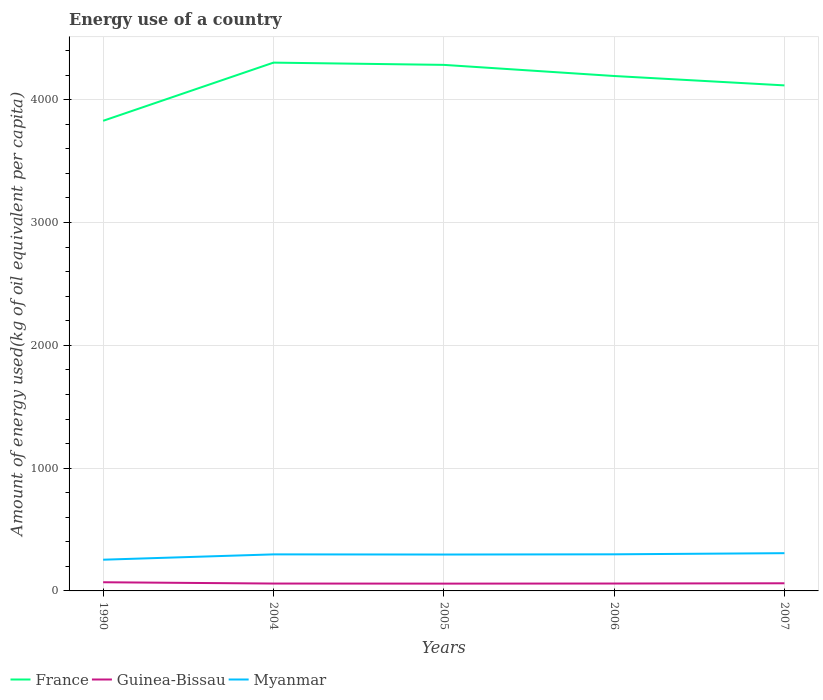How many different coloured lines are there?
Offer a terse response. 3. Does the line corresponding to France intersect with the line corresponding to Guinea-Bissau?
Provide a succinct answer. No. Across all years, what is the maximum amount of energy used in in Guinea-Bissau?
Give a very brief answer. 59.48. What is the total amount of energy used in in Guinea-Bissau in the graph?
Your response must be concise. -1.98. What is the difference between the highest and the second highest amount of energy used in in Myanmar?
Provide a succinct answer. 53.22. How many lines are there?
Offer a terse response. 3. How many years are there in the graph?
Ensure brevity in your answer.  5. What is the difference between two consecutive major ticks on the Y-axis?
Your response must be concise. 1000. Are the values on the major ticks of Y-axis written in scientific E-notation?
Offer a terse response. No. Does the graph contain grids?
Your answer should be very brief. Yes. Where does the legend appear in the graph?
Offer a very short reply. Bottom left. What is the title of the graph?
Offer a very short reply. Energy use of a country. What is the label or title of the Y-axis?
Keep it short and to the point. Amount of energy used(kg of oil equivalent per capita). What is the Amount of energy used(kg of oil equivalent per capita) of France in 1990?
Give a very brief answer. 3828.33. What is the Amount of energy used(kg of oil equivalent per capita) of Guinea-Bissau in 1990?
Offer a very short reply. 70.66. What is the Amount of energy used(kg of oil equivalent per capita) of Myanmar in 1990?
Give a very brief answer. 254.23. What is the Amount of energy used(kg of oil equivalent per capita) in France in 2004?
Offer a terse response. 4302.12. What is the Amount of energy used(kg of oil equivalent per capita) in Guinea-Bissau in 2004?
Your answer should be compact. 60.06. What is the Amount of energy used(kg of oil equivalent per capita) in Myanmar in 2004?
Make the answer very short. 297.64. What is the Amount of energy used(kg of oil equivalent per capita) in France in 2005?
Offer a terse response. 4283.8. What is the Amount of energy used(kg of oil equivalent per capita) of Guinea-Bissau in 2005?
Offer a terse response. 59.48. What is the Amount of energy used(kg of oil equivalent per capita) in Myanmar in 2005?
Give a very brief answer. 296.38. What is the Amount of energy used(kg of oil equivalent per capita) in France in 2006?
Give a very brief answer. 4193.22. What is the Amount of energy used(kg of oil equivalent per capita) of Guinea-Bissau in 2006?
Give a very brief answer. 60.22. What is the Amount of energy used(kg of oil equivalent per capita) in Myanmar in 2006?
Your response must be concise. 298.12. What is the Amount of energy used(kg of oil equivalent per capita) in France in 2007?
Make the answer very short. 4116.76. What is the Amount of energy used(kg of oil equivalent per capita) of Guinea-Bissau in 2007?
Provide a short and direct response. 62.2. What is the Amount of energy used(kg of oil equivalent per capita) of Myanmar in 2007?
Keep it short and to the point. 307.44. Across all years, what is the maximum Amount of energy used(kg of oil equivalent per capita) in France?
Provide a short and direct response. 4302.12. Across all years, what is the maximum Amount of energy used(kg of oil equivalent per capita) in Guinea-Bissau?
Your answer should be very brief. 70.66. Across all years, what is the maximum Amount of energy used(kg of oil equivalent per capita) of Myanmar?
Your answer should be very brief. 307.44. Across all years, what is the minimum Amount of energy used(kg of oil equivalent per capita) of France?
Provide a succinct answer. 3828.33. Across all years, what is the minimum Amount of energy used(kg of oil equivalent per capita) of Guinea-Bissau?
Your response must be concise. 59.48. Across all years, what is the minimum Amount of energy used(kg of oil equivalent per capita) in Myanmar?
Ensure brevity in your answer.  254.23. What is the total Amount of energy used(kg of oil equivalent per capita) in France in the graph?
Provide a succinct answer. 2.07e+04. What is the total Amount of energy used(kg of oil equivalent per capita) in Guinea-Bissau in the graph?
Give a very brief answer. 312.62. What is the total Amount of energy used(kg of oil equivalent per capita) of Myanmar in the graph?
Give a very brief answer. 1453.81. What is the difference between the Amount of energy used(kg of oil equivalent per capita) of France in 1990 and that in 2004?
Keep it short and to the point. -473.79. What is the difference between the Amount of energy used(kg of oil equivalent per capita) in Guinea-Bissau in 1990 and that in 2004?
Your answer should be compact. 10.6. What is the difference between the Amount of energy used(kg of oil equivalent per capita) in Myanmar in 1990 and that in 2004?
Provide a short and direct response. -43.42. What is the difference between the Amount of energy used(kg of oil equivalent per capita) in France in 1990 and that in 2005?
Offer a very short reply. -455.48. What is the difference between the Amount of energy used(kg of oil equivalent per capita) in Guinea-Bissau in 1990 and that in 2005?
Your response must be concise. 11.19. What is the difference between the Amount of energy used(kg of oil equivalent per capita) of Myanmar in 1990 and that in 2005?
Provide a short and direct response. -42.15. What is the difference between the Amount of energy used(kg of oil equivalent per capita) in France in 1990 and that in 2006?
Your answer should be compact. -364.89. What is the difference between the Amount of energy used(kg of oil equivalent per capita) of Guinea-Bissau in 1990 and that in 2006?
Keep it short and to the point. 10.45. What is the difference between the Amount of energy used(kg of oil equivalent per capita) of Myanmar in 1990 and that in 2006?
Keep it short and to the point. -43.89. What is the difference between the Amount of energy used(kg of oil equivalent per capita) of France in 1990 and that in 2007?
Provide a short and direct response. -288.43. What is the difference between the Amount of energy used(kg of oil equivalent per capita) in Guinea-Bissau in 1990 and that in 2007?
Make the answer very short. 8.46. What is the difference between the Amount of energy used(kg of oil equivalent per capita) of Myanmar in 1990 and that in 2007?
Offer a very short reply. -53.22. What is the difference between the Amount of energy used(kg of oil equivalent per capita) in France in 2004 and that in 2005?
Offer a terse response. 18.32. What is the difference between the Amount of energy used(kg of oil equivalent per capita) of Guinea-Bissau in 2004 and that in 2005?
Offer a very short reply. 0.59. What is the difference between the Amount of energy used(kg of oil equivalent per capita) in Myanmar in 2004 and that in 2005?
Give a very brief answer. 1.26. What is the difference between the Amount of energy used(kg of oil equivalent per capita) in France in 2004 and that in 2006?
Provide a short and direct response. 108.9. What is the difference between the Amount of energy used(kg of oil equivalent per capita) of Guinea-Bissau in 2004 and that in 2006?
Provide a short and direct response. -0.15. What is the difference between the Amount of energy used(kg of oil equivalent per capita) in Myanmar in 2004 and that in 2006?
Your response must be concise. -0.47. What is the difference between the Amount of energy used(kg of oil equivalent per capita) of France in 2004 and that in 2007?
Give a very brief answer. 185.36. What is the difference between the Amount of energy used(kg of oil equivalent per capita) of Guinea-Bissau in 2004 and that in 2007?
Make the answer very short. -2.14. What is the difference between the Amount of energy used(kg of oil equivalent per capita) of France in 2005 and that in 2006?
Your answer should be very brief. 90.58. What is the difference between the Amount of energy used(kg of oil equivalent per capita) in Guinea-Bissau in 2005 and that in 2006?
Make the answer very short. -0.74. What is the difference between the Amount of energy used(kg of oil equivalent per capita) of Myanmar in 2005 and that in 2006?
Offer a terse response. -1.74. What is the difference between the Amount of energy used(kg of oil equivalent per capita) of France in 2005 and that in 2007?
Make the answer very short. 167.04. What is the difference between the Amount of energy used(kg of oil equivalent per capita) of Guinea-Bissau in 2005 and that in 2007?
Offer a terse response. -2.72. What is the difference between the Amount of energy used(kg of oil equivalent per capita) in Myanmar in 2005 and that in 2007?
Offer a terse response. -11.06. What is the difference between the Amount of energy used(kg of oil equivalent per capita) in France in 2006 and that in 2007?
Keep it short and to the point. 76.46. What is the difference between the Amount of energy used(kg of oil equivalent per capita) of Guinea-Bissau in 2006 and that in 2007?
Your response must be concise. -1.98. What is the difference between the Amount of energy used(kg of oil equivalent per capita) in Myanmar in 2006 and that in 2007?
Offer a very short reply. -9.33. What is the difference between the Amount of energy used(kg of oil equivalent per capita) of France in 1990 and the Amount of energy used(kg of oil equivalent per capita) of Guinea-Bissau in 2004?
Your response must be concise. 3768.26. What is the difference between the Amount of energy used(kg of oil equivalent per capita) of France in 1990 and the Amount of energy used(kg of oil equivalent per capita) of Myanmar in 2004?
Give a very brief answer. 3530.68. What is the difference between the Amount of energy used(kg of oil equivalent per capita) in Guinea-Bissau in 1990 and the Amount of energy used(kg of oil equivalent per capita) in Myanmar in 2004?
Provide a succinct answer. -226.98. What is the difference between the Amount of energy used(kg of oil equivalent per capita) of France in 1990 and the Amount of energy used(kg of oil equivalent per capita) of Guinea-Bissau in 2005?
Give a very brief answer. 3768.85. What is the difference between the Amount of energy used(kg of oil equivalent per capita) of France in 1990 and the Amount of energy used(kg of oil equivalent per capita) of Myanmar in 2005?
Offer a terse response. 3531.95. What is the difference between the Amount of energy used(kg of oil equivalent per capita) of Guinea-Bissau in 1990 and the Amount of energy used(kg of oil equivalent per capita) of Myanmar in 2005?
Make the answer very short. -225.72. What is the difference between the Amount of energy used(kg of oil equivalent per capita) in France in 1990 and the Amount of energy used(kg of oil equivalent per capita) in Guinea-Bissau in 2006?
Give a very brief answer. 3768.11. What is the difference between the Amount of energy used(kg of oil equivalent per capita) of France in 1990 and the Amount of energy used(kg of oil equivalent per capita) of Myanmar in 2006?
Offer a terse response. 3530.21. What is the difference between the Amount of energy used(kg of oil equivalent per capita) in Guinea-Bissau in 1990 and the Amount of energy used(kg of oil equivalent per capita) in Myanmar in 2006?
Provide a succinct answer. -227.45. What is the difference between the Amount of energy used(kg of oil equivalent per capita) in France in 1990 and the Amount of energy used(kg of oil equivalent per capita) in Guinea-Bissau in 2007?
Your answer should be very brief. 3766.13. What is the difference between the Amount of energy used(kg of oil equivalent per capita) of France in 1990 and the Amount of energy used(kg of oil equivalent per capita) of Myanmar in 2007?
Your answer should be very brief. 3520.88. What is the difference between the Amount of energy used(kg of oil equivalent per capita) in Guinea-Bissau in 1990 and the Amount of energy used(kg of oil equivalent per capita) in Myanmar in 2007?
Offer a very short reply. -236.78. What is the difference between the Amount of energy used(kg of oil equivalent per capita) of France in 2004 and the Amount of energy used(kg of oil equivalent per capita) of Guinea-Bissau in 2005?
Your answer should be very brief. 4242.64. What is the difference between the Amount of energy used(kg of oil equivalent per capita) in France in 2004 and the Amount of energy used(kg of oil equivalent per capita) in Myanmar in 2005?
Provide a short and direct response. 4005.74. What is the difference between the Amount of energy used(kg of oil equivalent per capita) of Guinea-Bissau in 2004 and the Amount of energy used(kg of oil equivalent per capita) of Myanmar in 2005?
Ensure brevity in your answer.  -236.31. What is the difference between the Amount of energy used(kg of oil equivalent per capita) in France in 2004 and the Amount of energy used(kg of oil equivalent per capita) in Guinea-Bissau in 2006?
Keep it short and to the point. 4241.9. What is the difference between the Amount of energy used(kg of oil equivalent per capita) in France in 2004 and the Amount of energy used(kg of oil equivalent per capita) in Myanmar in 2006?
Your answer should be very brief. 4004. What is the difference between the Amount of energy used(kg of oil equivalent per capita) in Guinea-Bissau in 2004 and the Amount of energy used(kg of oil equivalent per capita) in Myanmar in 2006?
Ensure brevity in your answer.  -238.05. What is the difference between the Amount of energy used(kg of oil equivalent per capita) in France in 2004 and the Amount of energy used(kg of oil equivalent per capita) in Guinea-Bissau in 2007?
Make the answer very short. 4239.92. What is the difference between the Amount of energy used(kg of oil equivalent per capita) of France in 2004 and the Amount of energy used(kg of oil equivalent per capita) of Myanmar in 2007?
Give a very brief answer. 3994.68. What is the difference between the Amount of energy used(kg of oil equivalent per capita) in Guinea-Bissau in 2004 and the Amount of energy used(kg of oil equivalent per capita) in Myanmar in 2007?
Your answer should be very brief. -247.38. What is the difference between the Amount of energy used(kg of oil equivalent per capita) of France in 2005 and the Amount of energy used(kg of oil equivalent per capita) of Guinea-Bissau in 2006?
Ensure brevity in your answer.  4223.59. What is the difference between the Amount of energy used(kg of oil equivalent per capita) of France in 2005 and the Amount of energy used(kg of oil equivalent per capita) of Myanmar in 2006?
Your answer should be very brief. 3985.69. What is the difference between the Amount of energy used(kg of oil equivalent per capita) in Guinea-Bissau in 2005 and the Amount of energy used(kg of oil equivalent per capita) in Myanmar in 2006?
Ensure brevity in your answer.  -238.64. What is the difference between the Amount of energy used(kg of oil equivalent per capita) in France in 2005 and the Amount of energy used(kg of oil equivalent per capita) in Guinea-Bissau in 2007?
Keep it short and to the point. 4221.6. What is the difference between the Amount of energy used(kg of oil equivalent per capita) of France in 2005 and the Amount of energy used(kg of oil equivalent per capita) of Myanmar in 2007?
Give a very brief answer. 3976.36. What is the difference between the Amount of energy used(kg of oil equivalent per capita) of Guinea-Bissau in 2005 and the Amount of energy used(kg of oil equivalent per capita) of Myanmar in 2007?
Your response must be concise. -247.97. What is the difference between the Amount of energy used(kg of oil equivalent per capita) in France in 2006 and the Amount of energy used(kg of oil equivalent per capita) in Guinea-Bissau in 2007?
Give a very brief answer. 4131.02. What is the difference between the Amount of energy used(kg of oil equivalent per capita) in France in 2006 and the Amount of energy used(kg of oil equivalent per capita) in Myanmar in 2007?
Keep it short and to the point. 3885.78. What is the difference between the Amount of energy used(kg of oil equivalent per capita) of Guinea-Bissau in 2006 and the Amount of energy used(kg of oil equivalent per capita) of Myanmar in 2007?
Your answer should be very brief. -247.23. What is the average Amount of energy used(kg of oil equivalent per capita) in France per year?
Provide a short and direct response. 4144.85. What is the average Amount of energy used(kg of oil equivalent per capita) of Guinea-Bissau per year?
Your response must be concise. 62.52. What is the average Amount of energy used(kg of oil equivalent per capita) in Myanmar per year?
Your answer should be compact. 290.76. In the year 1990, what is the difference between the Amount of energy used(kg of oil equivalent per capita) in France and Amount of energy used(kg of oil equivalent per capita) in Guinea-Bissau?
Your answer should be very brief. 3757.66. In the year 1990, what is the difference between the Amount of energy used(kg of oil equivalent per capita) in France and Amount of energy used(kg of oil equivalent per capita) in Myanmar?
Provide a short and direct response. 3574.1. In the year 1990, what is the difference between the Amount of energy used(kg of oil equivalent per capita) in Guinea-Bissau and Amount of energy used(kg of oil equivalent per capita) in Myanmar?
Offer a terse response. -183.56. In the year 2004, what is the difference between the Amount of energy used(kg of oil equivalent per capita) in France and Amount of energy used(kg of oil equivalent per capita) in Guinea-Bissau?
Your answer should be very brief. 4242.06. In the year 2004, what is the difference between the Amount of energy used(kg of oil equivalent per capita) in France and Amount of energy used(kg of oil equivalent per capita) in Myanmar?
Your answer should be very brief. 4004.48. In the year 2004, what is the difference between the Amount of energy used(kg of oil equivalent per capita) of Guinea-Bissau and Amount of energy used(kg of oil equivalent per capita) of Myanmar?
Provide a short and direct response. -237.58. In the year 2005, what is the difference between the Amount of energy used(kg of oil equivalent per capita) of France and Amount of energy used(kg of oil equivalent per capita) of Guinea-Bissau?
Make the answer very short. 4224.33. In the year 2005, what is the difference between the Amount of energy used(kg of oil equivalent per capita) in France and Amount of energy used(kg of oil equivalent per capita) in Myanmar?
Your answer should be compact. 3987.42. In the year 2005, what is the difference between the Amount of energy used(kg of oil equivalent per capita) in Guinea-Bissau and Amount of energy used(kg of oil equivalent per capita) in Myanmar?
Offer a very short reply. -236.9. In the year 2006, what is the difference between the Amount of energy used(kg of oil equivalent per capita) of France and Amount of energy used(kg of oil equivalent per capita) of Guinea-Bissau?
Your response must be concise. 4133. In the year 2006, what is the difference between the Amount of energy used(kg of oil equivalent per capita) in France and Amount of energy used(kg of oil equivalent per capita) in Myanmar?
Offer a terse response. 3895.11. In the year 2006, what is the difference between the Amount of energy used(kg of oil equivalent per capita) of Guinea-Bissau and Amount of energy used(kg of oil equivalent per capita) of Myanmar?
Offer a very short reply. -237.9. In the year 2007, what is the difference between the Amount of energy used(kg of oil equivalent per capita) in France and Amount of energy used(kg of oil equivalent per capita) in Guinea-Bissau?
Offer a terse response. 4054.56. In the year 2007, what is the difference between the Amount of energy used(kg of oil equivalent per capita) in France and Amount of energy used(kg of oil equivalent per capita) in Myanmar?
Make the answer very short. 3809.32. In the year 2007, what is the difference between the Amount of energy used(kg of oil equivalent per capita) in Guinea-Bissau and Amount of energy used(kg of oil equivalent per capita) in Myanmar?
Ensure brevity in your answer.  -245.24. What is the ratio of the Amount of energy used(kg of oil equivalent per capita) of France in 1990 to that in 2004?
Offer a terse response. 0.89. What is the ratio of the Amount of energy used(kg of oil equivalent per capita) in Guinea-Bissau in 1990 to that in 2004?
Ensure brevity in your answer.  1.18. What is the ratio of the Amount of energy used(kg of oil equivalent per capita) of Myanmar in 1990 to that in 2004?
Offer a very short reply. 0.85. What is the ratio of the Amount of energy used(kg of oil equivalent per capita) of France in 1990 to that in 2005?
Ensure brevity in your answer.  0.89. What is the ratio of the Amount of energy used(kg of oil equivalent per capita) of Guinea-Bissau in 1990 to that in 2005?
Make the answer very short. 1.19. What is the ratio of the Amount of energy used(kg of oil equivalent per capita) in Myanmar in 1990 to that in 2005?
Make the answer very short. 0.86. What is the ratio of the Amount of energy used(kg of oil equivalent per capita) of Guinea-Bissau in 1990 to that in 2006?
Ensure brevity in your answer.  1.17. What is the ratio of the Amount of energy used(kg of oil equivalent per capita) in Myanmar in 1990 to that in 2006?
Your answer should be very brief. 0.85. What is the ratio of the Amount of energy used(kg of oil equivalent per capita) of France in 1990 to that in 2007?
Offer a terse response. 0.93. What is the ratio of the Amount of energy used(kg of oil equivalent per capita) in Guinea-Bissau in 1990 to that in 2007?
Keep it short and to the point. 1.14. What is the ratio of the Amount of energy used(kg of oil equivalent per capita) in Myanmar in 1990 to that in 2007?
Provide a short and direct response. 0.83. What is the ratio of the Amount of energy used(kg of oil equivalent per capita) of Guinea-Bissau in 2004 to that in 2005?
Your answer should be compact. 1.01. What is the ratio of the Amount of energy used(kg of oil equivalent per capita) of Myanmar in 2004 to that in 2005?
Provide a short and direct response. 1. What is the ratio of the Amount of energy used(kg of oil equivalent per capita) of France in 2004 to that in 2006?
Ensure brevity in your answer.  1.03. What is the ratio of the Amount of energy used(kg of oil equivalent per capita) in Guinea-Bissau in 2004 to that in 2006?
Your answer should be compact. 1. What is the ratio of the Amount of energy used(kg of oil equivalent per capita) in Myanmar in 2004 to that in 2006?
Your answer should be very brief. 1. What is the ratio of the Amount of energy used(kg of oil equivalent per capita) of France in 2004 to that in 2007?
Your response must be concise. 1.04. What is the ratio of the Amount of energy used(kg of oil equivalent per capita) of Guinea-Bissau in 2004 to that in 2007?
Your answer should be very brief. 0.97. What is the ratio of the Amount of energy used(kg of oil equivalent per capita) in Myanmar in 2004 to that in 2007?
Keep it short and to the point. 0.97. What is the ratio of the Amount of energy used(kg of oil equivalent per capita) in France in 2005 to that in 2006?
Give a very brief answer. 1.02. What is the ratio of the Amount of energy used(kg of oil equivalent per capita) in Guinea-Bissau in 2005 to that in 2006?
Your response must be concise. 0.99. What is the ratio of the Amount of energy used(kg of oil equivalent per capita) of Myanmar in 2005 to that in 2006?
Make the answer very short. 0.99. What is the ratio of the Amount of energy used(kg of oil equivalent per capita) in France in 2005 to that in 2007?
Ensure brevity in your answer.  1.04. What is the ratio of the Amount of energy used(kg of oil equivalent per capita) in Guinea-Bissau in 2005 to that in 2007?
Offer a terse response. 0.96. What is the ratio of the Amount of energy used(kg of oil equivalent per capita) of Myanmar in 2005 to that in 2007?
Provide a short and direct response. 0.96. What is the ratio of the Amount of energy used(kg of oil equivalent per capita) of France in 2006 to that in 2007?
Keep it short and to the point. 1.02. What is the ratio of the Amount of energy used(kg of oil equivalent per capita) of Guinea-Bissau in 2006 to that in 2007?
Your answer should be compact. 0.97. What is the ratio of the Amount of energy used(kg of oil equivalent per capita) of Myanmar in 2006 to that in 2007?
Your response must be concise. 0.97. What is the difference between the highest and the second highest Amount of energy used(kg of oil equivalent per capita) in France?
Keep it short and to the point. 18.32. What is the difference between the highest and the second highest Amount of energy used(kg of oil equivalent per capita) in Guinea-Bissau?
Make the answer very short. 8.46. What is the difference between the highest and the second highest Amount of energy used(kg of oil equivalent per capita) of Myanmar?
Your answer should be very brief. 9.33. What is the difference between the highest and the lowest Amount of energy used(kg of oil equivalent per capita) of France?
Provide a succinct answer. 473.79. What is the difference between the highest and the lowest Amount of energy used(kg of oil equivalent per capita) in Guinea-Bissau?
Keep it short and to the point. 11.19. What is the difference between the highest and the lowest Amount of energy used(kg of oil equivalent per capita) of Myanmar?
Provide a succinct answer. 53.22. 